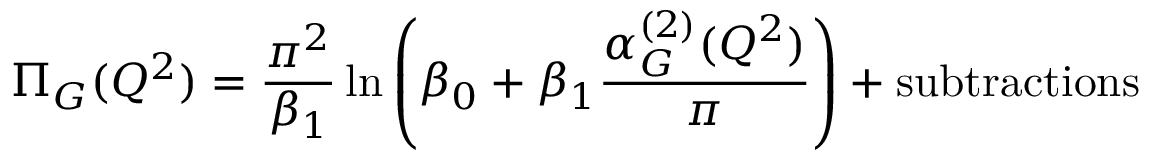Convert formula to latex. <formula><loc_0><loc_0><loc_500><loc_500>\Pi _ { G } ( Q ^ { 2 } ) = \frac { \pi ^ { 2 } } { \beta _ { 1 } } \ln \left ( \beta _ { 0 } + \beta _ { 1 } \frac { \alpha _ { G } ^ { ( 2 ) } ( Q ^ { 2 } ) } { \pi } \right ) + s u b t r a c t i o n s</formula> 